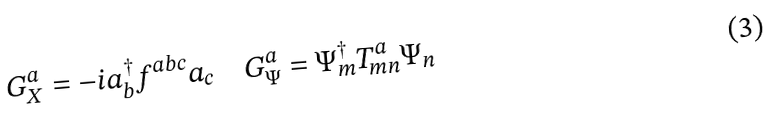Convert formula to latex. <formula><loc_0><loc_0><loc_500><loc_500>G ^ { a } _ { X } = - i a ^ { \dag } _ { b } f ^ { a b c } a _ { c } \quad G ^ { a } _ { \Psi } = \Psi ^ { \dag } _ { m } T ^ { a } _ { m n } \Psi _ { n }</formula> 